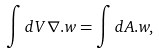Convert formula to latex. <formula><loc_0><loc_0><loc_500><loc_500>\int d V { \nabla } . { w } = \int d { A } . { w } ,</formula> 